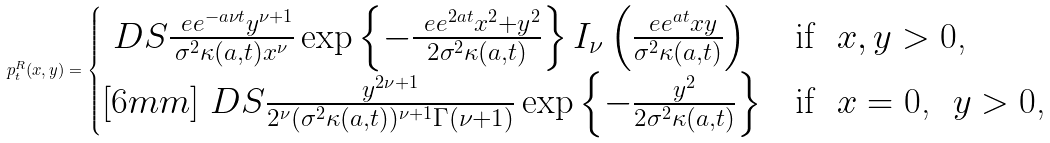Convert formula to latex. <formula><loc_0><loc_0><loc_500><loc_500>p _ { t } ^ { R } ( x , y ) = \begin{cases} \ D S \frac { \ e e ^ { - a \nu t } y ^ { \nu + 1 } } { \sigma ^ { 2 } \kappa ( a , t ) x ^ { \nu } } \exp \left \{ - \frac { \ e e ^ { 2 a t } x ^ { 2 } + y ^ { 2 } } { 2 \sigma ^ { 2 } \kappa ( a , t ) } \right \} I _ { \nu } \left ( \frac { \ e e ^ { a t } x y } { \sigma ^ { 2 } \kappa ( a , t ) } \right ) & \text {if \ $x,y>0$,} \\ [ 6 m m ] \ D S \frac { y ^ { 2 \nu + 1 } } { 2 ^ { \nu } ( \sigma ^ { 2 } \kappa ( a , t ) ) ^ { \nu + 1 } \Gamma ( \nu + 1 ) } \exp \left \{ - \frac { y ^ { 2 } } { 2 \sigma ^ { 2 } \kappa ( a , t ) } \right \} & \text {if \ $x=0$, \ $y>0$,} \end{cases}</formula> 